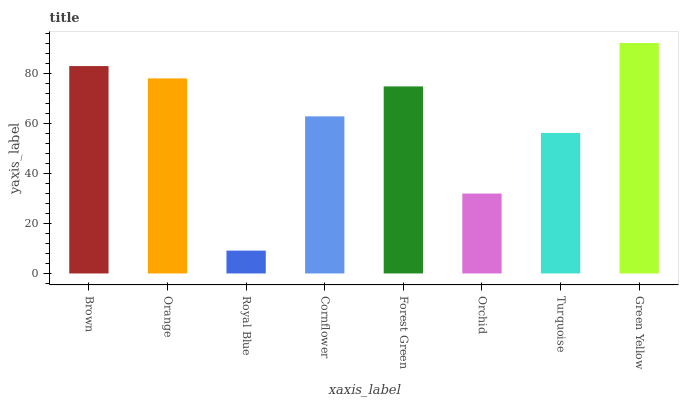Is Royal Blue the minimum?
Answer yes or no. Yes. Is Green Yellow the maximum?
Answer yes or no. Yes. Is Orange the minimum?
Answer yes or no. No. Is Orange the maximum?
Answer yes or no. No. Is Brown greater than Orange?
Answer yes or no. Yes. Is Orange less than Brown?
Answer yes or no. Yes. Is Orange greater than Brown?
Answer yes or no. No. Is Brown less than Orange?
Answer yes or no. No. Is Forest Green the high median?
Answer yes or no. Yes. Is Cornflower the low median?
Answer yes or no. Yes. Is Brown the high median?
Answer yes or no. No. Is Green Yellow the low median?
Answer yes or no. No. 